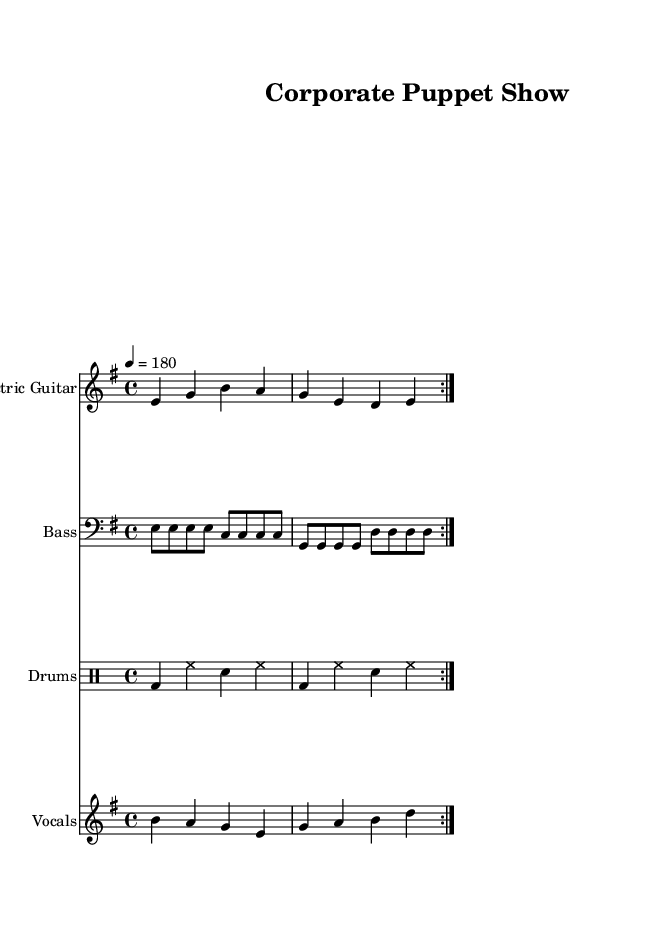What is the key signature of this music? The key signature is identified by the number of sharps or flats displayed at the beginning of the staff. In this case, the 'E minor' key signature has one sharp (F#).
Answer: E minor What is the time signature of this music? The time signature indicates how many beats are in each measure. Here, it is shown as '4/4', meaning there are four quarter-note beats per measure.
Answer: 4/4 What is the tempo marking for this piece? The tempo is indicated at the beginning with a number representing beats per minute. Here, it is marked as '4 = 180', indicating a fast pace.
Answer: 180 How many measures are in the verse section? To find the number of measures, count the bars in the vocally labeled section. In this example, there are 2 measures of vocals in the verse.
Answer: 2 What instruments are featured in this sheet music? The instruments are identified in the staff naming sections. This sheet music features Electric Guitar, Bass, Drums, and Vocals.
Answer: Electric Guitar, Bass, Drums, Vocals What thematic element is expressed in the provided lyrics? The lyrics present themes of discontent against corporate and political corruption, as indicated by the terms used like 'suits', 'dollar bills' suggesting greed and influence.
Answer: Corruption What rhythmic pattern do the drums follow in the repeating section? By observing the drum notation, it's clear that the pattern consists of bass drum hits followed by hi-hat and snare placements. The repeated section has a straightforward, driving rhythm: bass-hat-snare-hat.
Answer: Bass, hi-hat, snare 